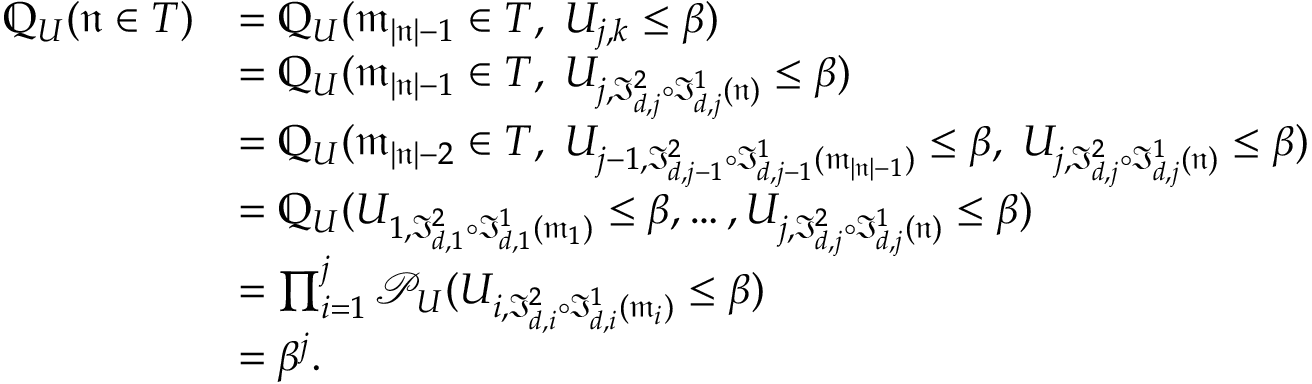<formula> <loc_0><loc_0><loc_500><loc_500>\begin{array} { r l } { \mathbb { Q } _ { U } ( \mathfrak n \in T ) } & { = \mathbb { Q } _ { U } ( \mathfrak m _ { | \mathfrak n | - 1 } \in T , \, U _ { j , k } \leq \beta ) } \\ & { = \mathbb { Q } _ { U } ( \mathfrak m _ { | \mathfrak n | - 1 } \in T , \, U _ { j , \mathfrak I _ { d , j } ^ { 2 } \circ \mathfrak I _ { d , j } ^ { 1 } ( \mathfrak n ) } \leq \beta ) } \\ & { = \mathbb { Q } _ { U } ( \mathfrak m _ { | \mathfrak n | - 2 } \in T , \, U _ { j - 1 , \mathfrak I _ { d , j - 1 } ^ { 2 } \circ \mathfrak I _ { d , j - 1 } ^ { 1 } ( \mathfrak m _ { | \mathfrak n | - 1 } ) } \leq \beta , \, U _ { j , \mathfrak I _ { d , j } ^ { 2 } \circ \mathfrak I _ { d , j } ^ { 1 } ( \mathfrak n ) } \leq \beta ) } \\ & { = \mathbb { Q } _ { U } ( U _ { 1 , \mathfrak I _ { d , 1 } ^ { 2 } \circ \mathfrak I _ { d , 1 } ^ { 1 } ( \mathfrak m _ { 1 } ) } \leq \beta , \dots , U _ { j , \mathfrak I _ { d , j } ^ { 2 } \circ \mathfrak I _ { d , j } ^ { 1 } ( \mathfrak n ) } \leq \beta ) } \\ & { = \prod _ { i = 1 } ^ { j } \mathcal { P } _ { U } ( U _ { i , \mathfrak I _ { d , i } ^ { 2 } \circ \mathfrak I _ { d , i } ^ { 1 } ( \mathfrak m _ { i } ) } \leq \beta ) } \\ & { = \beta ^ { j } . } \end{array}</formula> 